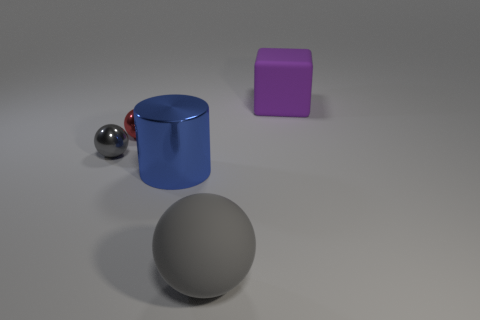Is the material of the purple block the same as the gray thing that is right of the large shiny object?
Provide a short and direct response. Yes. What shape is the gray object left of the big rubber thing in front of the purple matte object?
Your response must be concise. Sphere. There is a metal object that is in front of the red metal ball and left of the large metallic cylinder; what shape is it?
Offer a very short reply. Sphere. What number of things are tiny red shiny objects or things to the left of the large matte ball?
Provide a short and direct response. 3. There is a red thing that is the same shape as the big gray thing; what material is it?
Offer a very short reply. Metal. There is a ball that is both to the right of the gray metallic ball and behind the blue thing; what material is it?
Ensure brevity in your answer.  Metal. What number of big gray things are the same shape as the tiny red metallic object?
Offer a terse response. 1. There is a rubber object on the right side of the large rubber thing that is in front of the purple object; what color is it?
Offer a terse response. Purple. Are there an equal number of matte blocks that are behind the big purple matte object and gray matte things?
Keep it short and to the point. No. Is there a metal ball of the same size as the gray metallic thing?
Ensure brevity in your answer.  Yes. 